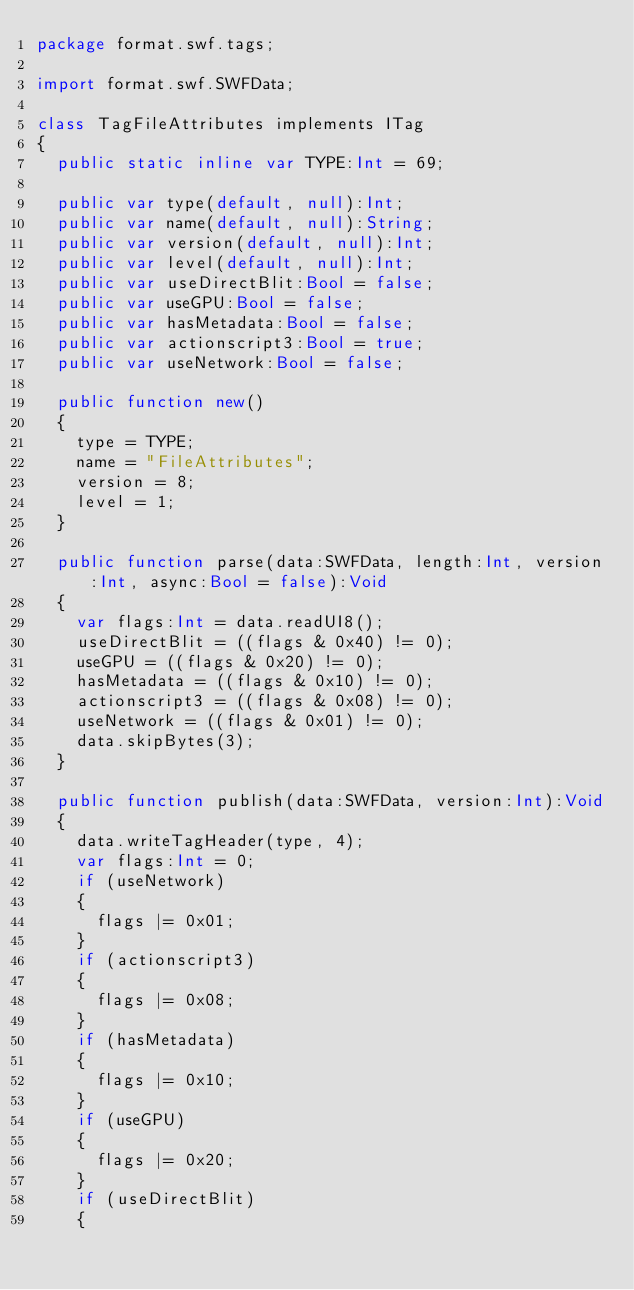Convert code to text. <code><loc_0><loc_0><loc_500><loc_500><_Haxe_>package format.swf.tags;

import format.swf.SWFData;

class TagFileAttributes implements ITag
{
	public static inline var TYPE:Int = 69;

	public var type(default, null):Int;
	public var name(default, null):String;
	public var version(default, null):Int;
	public var level(default, null):Int;
	public var useDirectBlit:Bool = false;
	public var useGPU:Bool = false;
	public var hasMetadata:Bool = false;
	public var actionscript3:Bool = true;
	public var useNetwork:Bool = false;

	public function new()
	{
		type = TYPE;
		name = "FileAttributes";
		version = 8;
		level = 1;
	}

	public function parse(data:SWFData, length:Int, version:Int, async:Bool = false):Void
	{
		var flags:Int = data.readUI8();
		useDirectBlit = ((flags & 0x40) != 0);
		useGPU = ((flags & 0x20) != 0);
		hasMetadata = ((flags & 0x10) != 0);
		actionscript3 = ((flags & 0x08) != 0);
		useNetwork = ((flags & 0x01) != 0);
		data.skipBytes(3);
	}

	public function publish(data:SWFData, version:Int):Void
	{
		data.writeTagHeader(type, 4);
		var flags:Int = 0;
		if (useNetwork)
		{
			flags |= 0x01;
		}
		if (actionscript3)
		{
			flags |= 0x08;
		}
		if (hasMetadata)
		{
			flags |= 0x10;
		}
		if (useGPU)
		{
			flags |= 0x20;
		}
		if (useDirectBlit)
		{</code> 